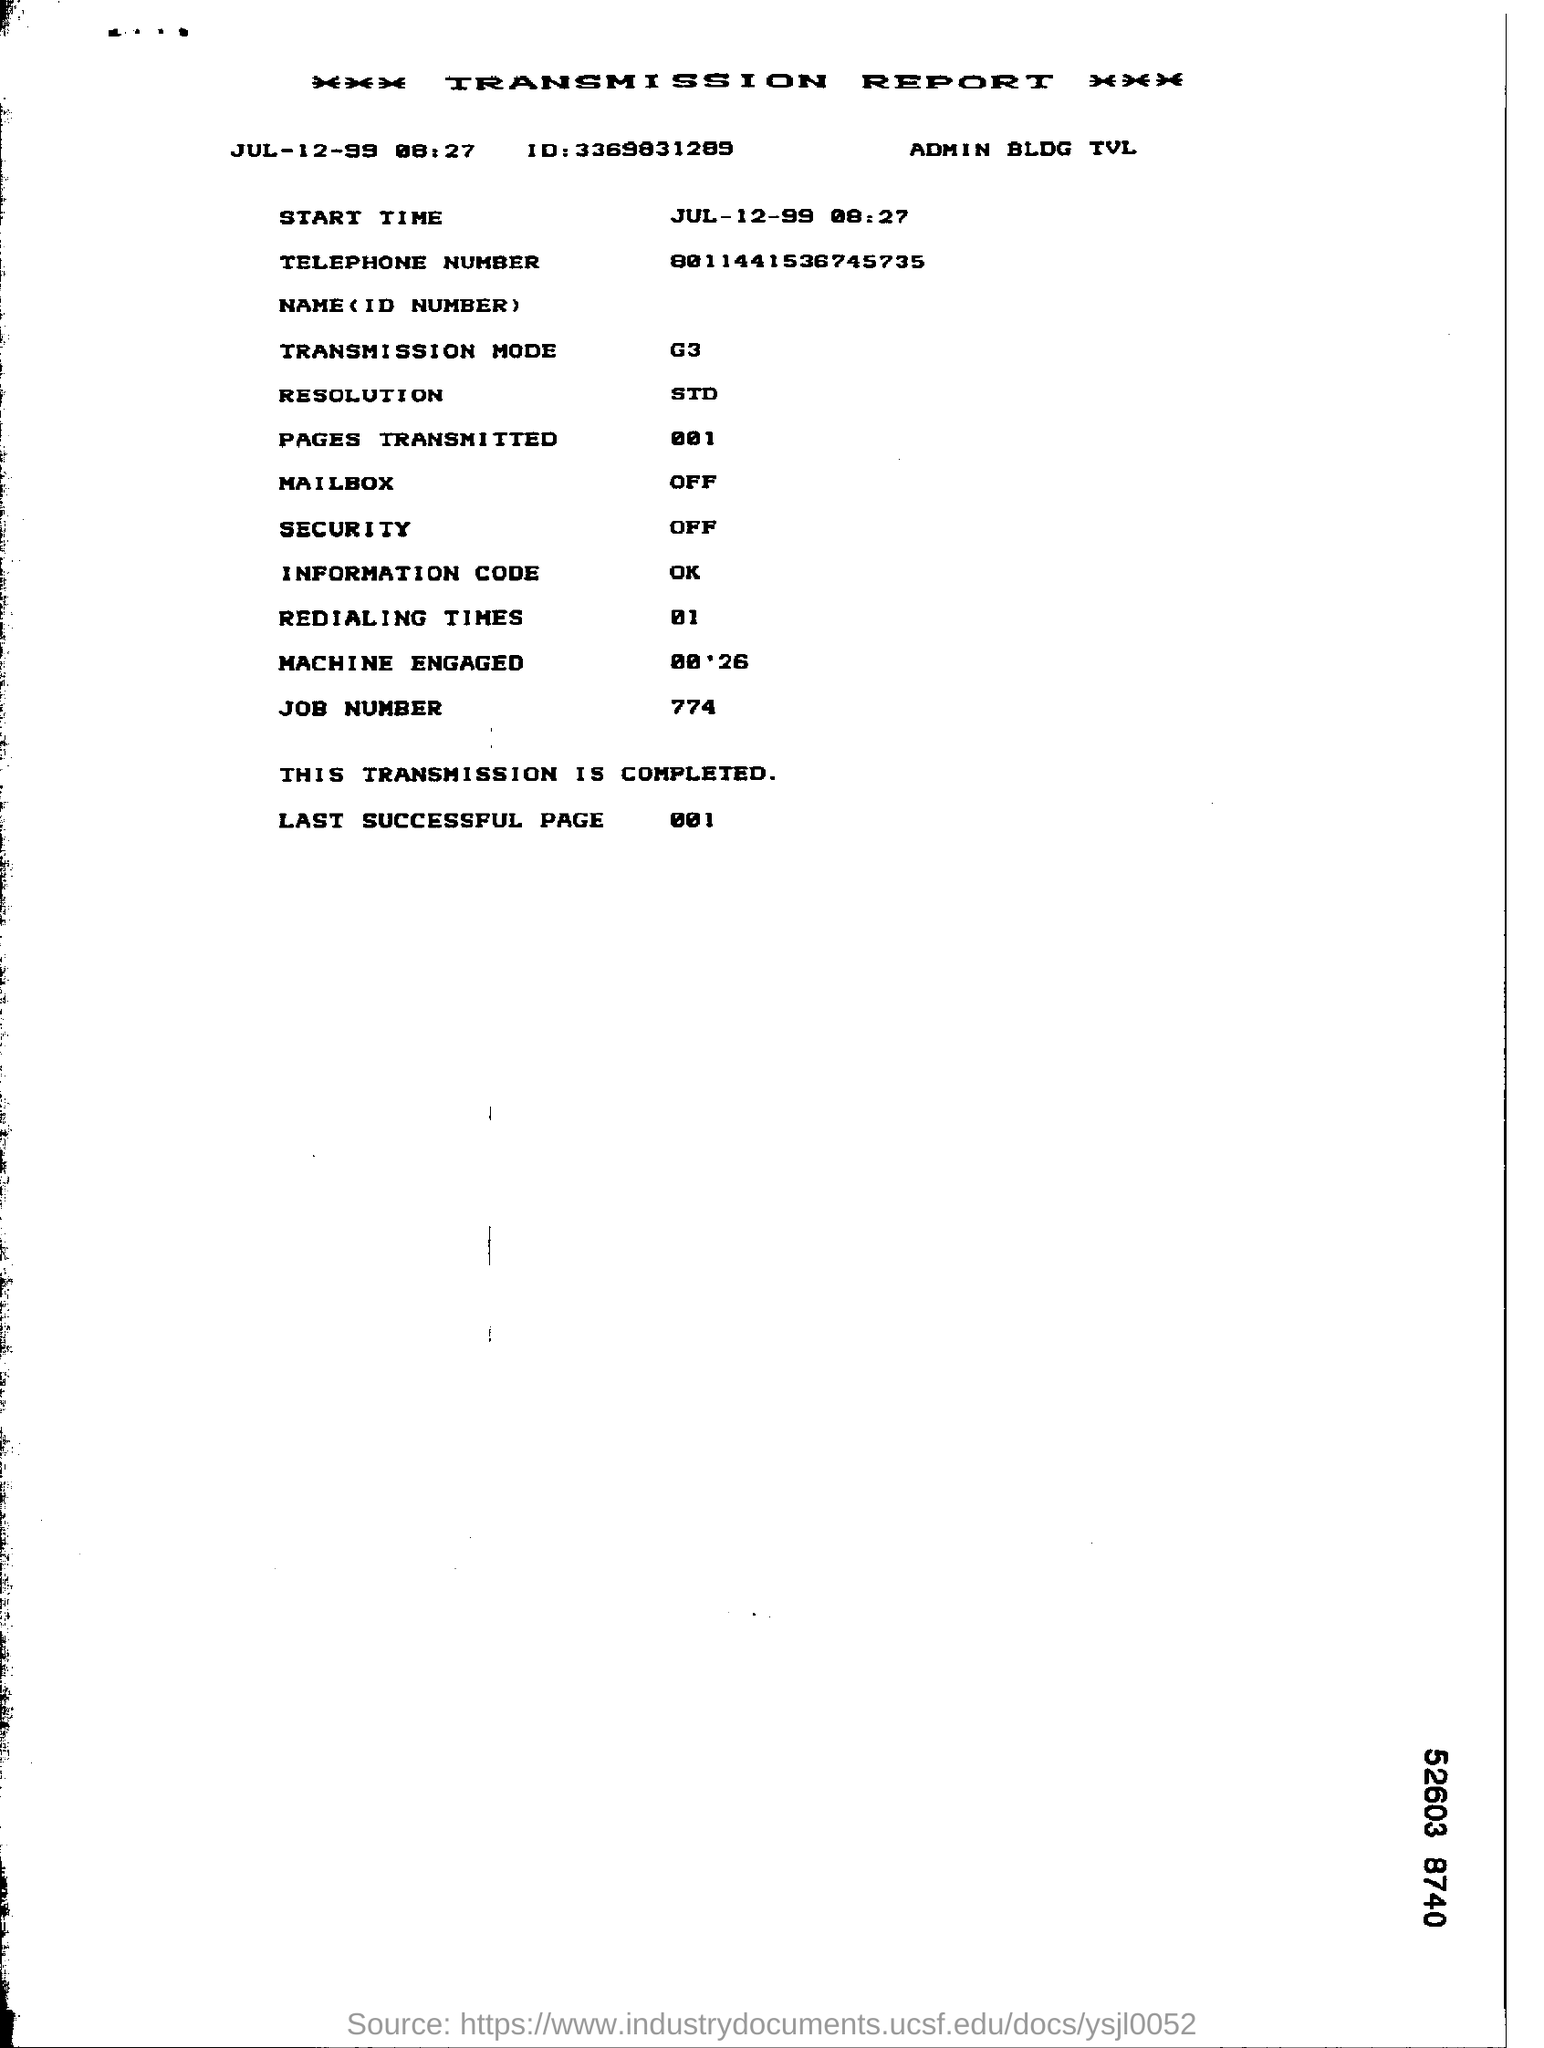What is the date mentioned in the transmission report ?
Provide a succinct answer. JUL-12-99. What is the transmission mode mentioned in the report ?
Provide a short and direct response. G3. How many pages are transmitted in the report ?
Your answer should be very brief. 001. What is the job number given in the report ?
Offer a terse response. 774. What is the number of redialing times mentioned in the report ?
Ensure brevity in your answer.  01. What is the information code given in the report ?
Your answer should be very brief. Ok. What is the status of the mailbox given in the transmission report ?
Ensure brevity in your answer.  OFF. What is the status of the security in the transmission report ?
Offer a terse response. OFF. 